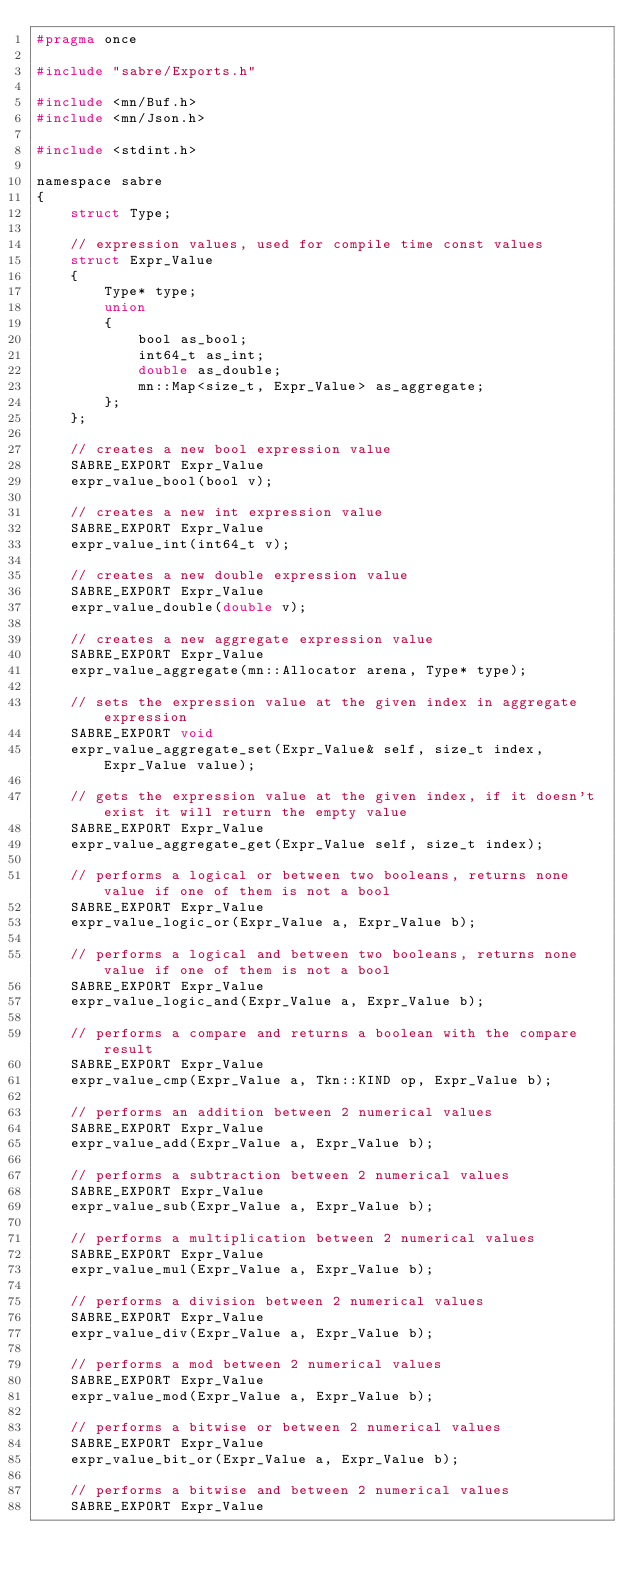Convert code to text. <code><loc_0><loc_0><loc_500><loc_500><_C_>#pragma once

#include "sabre/Exports.h"

#include <mn/Buf.h>
#include <mn/Json.h>

#include <stdint.h>

namespace sabre
{
	struct Type;

	// expression values, used for compile time const values
	struct Expr_Value
	{
		Type* type;
		union
		{
			bool as_bool;
			int64_t as_int;
			double as_double;
			mn::Map<size_t, Expr_Value> as_aggregate;
		};
	};

	// creates a new bool expression value
	SABRE_EXPORT Expr_Value
	expr_value_bool(bool v);

	// creates a new int expression value
	SABRE_EXPORT Expr_Value
	expr_value_int(int64_t v);

	// creates a new double expression value
	SABRE_EXPORT Expr_Value
	expr_value_double(double v);

	// creates a new aggregate expression value
	SABRE_EXPORT Expr_Value
	expr_value_aggregate(mn::Allocator arena, Type* type);

	// sets the expression value at the given index in aggregate expression
	SABRE_EXPORT void
	expr_value_aggregate_set(Expr_Value& self, size_t index, Expr_Value value);

	// gets the expression value at the given index, if it doesn't exist it will return the empty value
	SABRE_EXPORT Expr_Value
	expr_value_aggregate_get(Expr_Value self, size_t index);

	// performs a logical or between two booleans, returns none value if one of them is not a bool
	SABRE_EXPORT Expr_Value
	expr_value_logic_or(Expr_Value a, Expr_Value b);

	// performs a logical and between two booleans, returns none value if one of them is not a bool
	SABRE_EXPORT Expr_Value
	expr_value_logic_and(Expr_Value a, Expr_Value b);

	// performs a compare and returns a boolean with the compare result
	SABRE_EXPORT Expr_Value
	expr_value_cmp(Expr_Value a, Tkn::KIND op, Expr_Value b);

	// performs an addition between 2 numerical values
	SABRE_EXPORT Expr_Value
	expr_value_add(Expr_Value a, Expr_Value b);

	// performs a subtraction between 2 numerical values
	SABRE_EXPORT Expr_Value
	expr_value_sub(Expr_Value a, Expr_Value b);

	// performs a multiplication between 2 numerical values
	SABRE_EXPORT Expr_Value
	expr_value_mul(Expr_Value a, Expr_Value b);

	// performs a division between 2 numerical values
	SABRE_EXPORT Expr_Value
	expr_value_div(Expr_Value a, Expr_Value b);

	// performs a mod between 2 numerical values
	SABRE_EXPORT Expr_Value
	expr_value_mod(Expr_Value a, Expr_Value b);

	// performs a bitwise or between 2 numerical values
	SABRE_EXPORT Expr_Value
	expr_value_bit_or(Expr_Value a, Expr_Value b);

	// performs a bitwise and between 2 numerical values
	SABRE_EXPORT Expr_Value</code> 